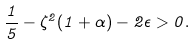Convert formula to latex. <formula><loc_0><loc_0><loc_500><loc_500>\frac { 1 } { 5 } - \zeta ^ { 2 } ( 1 + \alpha ) - 2 \epsilon > 0 .</formula> 